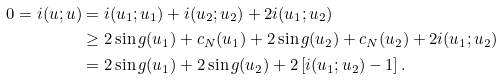<formula> <loc_0><loc_0><loc_500><loc_500>0 = i ( u ; u ) & = i ( u _ { 1 } ; u _ { 1 } ) + i ( u _ { 2 } ; u _ { 2 } ) + 2 i ( u _ { 1 } ; u _ { 2 } ) \\ & \geq 2 \sin g ( u _ { 1 } ) + c _ { N } ( u _ { 1 } ) + 2 \sin g ( u _ { 2 } ) + c _ { N } ( u _ { 2 } ) + 2 i ( u _ { 1 } ; u _ { 2 } ) \\ & = 2 \sin g ( u _ { 1 } ) + 2 \sin g ( u _ { 2 } ) + 2 \left [ i ( u _ { 1 } ; u _ { 2 } ) - 1 \right ] .</formula> 